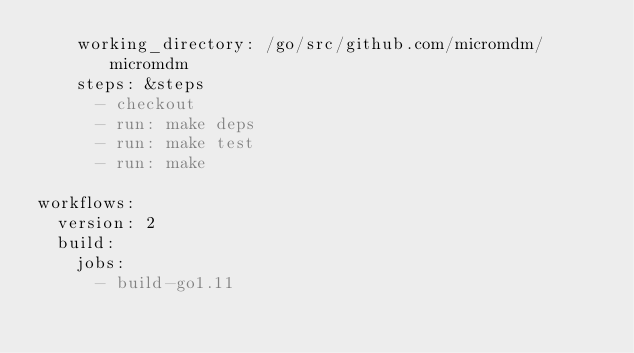Convert code to text. <code><loc_0><loc_0><loc_500><loc_500><_YAML_>    working_directory: /go/src/github.com/micromdm/micromdm
    steps: &steps
      - checkout
      - run: make deps
      - run: make test
      - run: make

workflows:
  version: 2
  build:
    jobs:
      - build-go1.11
</code> 